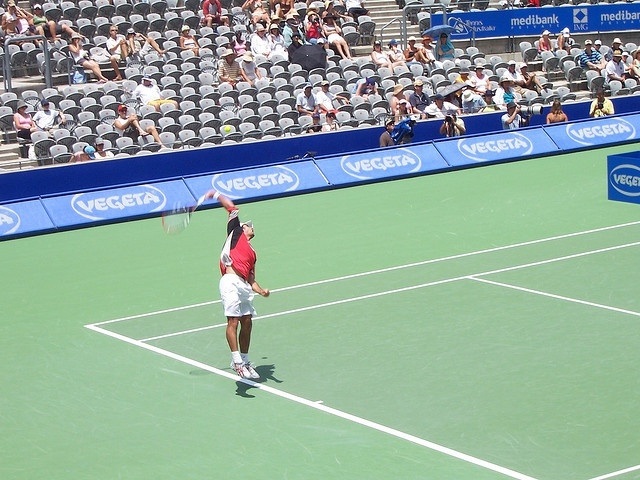Describe the objects in this image and their specific colors. I can see chair in black, lightgray, gray, and darkgray tones, people in black, lightgray, gray, and darkgray tones, people in black, white, darkgray, salmon, and maroon tones, tennis racket in black, lightgreen, darkgray, lightblue, and gray tones, and people in black, white, tan, and gray tones in this image. 